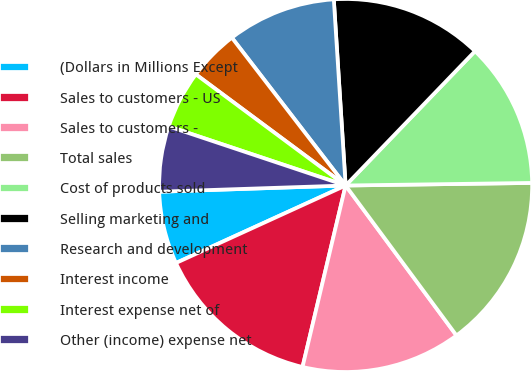Convert chart. <chart><loc_0><loc_0><loc_500><loc_500><pie_chart><fcel>(Dollars in Millions Except<fcel>Sales to customers - US<fcel>Sales to customers -<fcel>Total sales<fcel>Cost of products sold<fcel>Selling marketing and<fcel>Research and development<fcel>Interest income<fcel>Interest expense net of<fcel>Other (income) expense net<nl><fcel>6.29%<fcel>14.47%<fcel>13.84%<fcel>15.09%<fcel>12.58%<fcel>13.21%<fcel>9.43%<fcel>4.4%<fcel>5.03%<fcel>5.66%<nl></chart> 